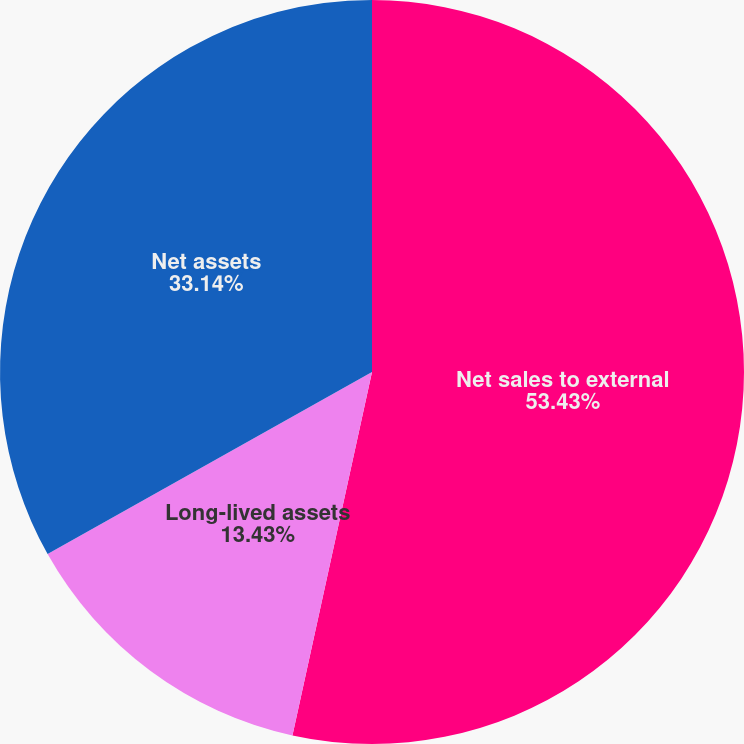<chart> <loc_0><loc_0><loc_500><loc_500><pie_chart><fcel>Net sales to external<fcel>Long-lived assets<fcel>Net assets<nl><fcel>53.43%<fcel>13.43%<fcel>33.14%<nl></chart> 